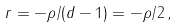<formula> <loc_0><loc_0><loc_500><loc_500>r = - \rho / ( d - 1 ) = - \rho / 2 \, ,</formula> 